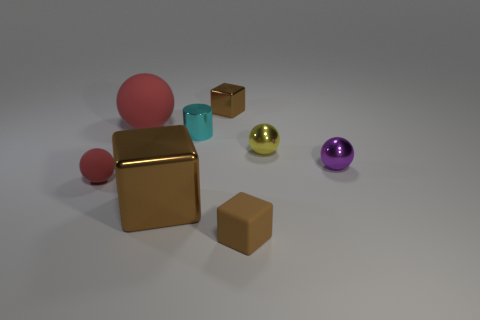What is the color of the matte cube that is the same size as the cyan thing?
Give a very brief answer. Brown. How many small things are blue metallic cylinders or shiny blocks?
Give a very brief answer. 1. Are there more brown things behind the big metallic thing than tiny metallic cylinders that are right of the yellow shiny ball?
Keep it short and to the point. Yes. What is the size of the matte thing that is the same color as the tiny rubber ball?
Keep it short and to the point. Large. What number of other things are the same size as the cylinder?
Your response must be concise. 5. Does the block behind the small cyan shiny thing have the same material as the big brown object?
Give a very brief answer. Yes. What number of other things are the same color as the matte cube?
Offer a very short reply. 2. How many other things are there of the same shape as the cyan shiny object?
Offer a very short reply. 0. Does the tiny thing behind the big red rubber thing have the same shape as the red thing to the right of the tiny red matte ball?
Offer a very short reply. No. Is the number of small cylinders behind the small cyan thing the same as the number of small metallic balls that are in front of the large brown metallic cube?
Your answer should be very brief. Yes. 